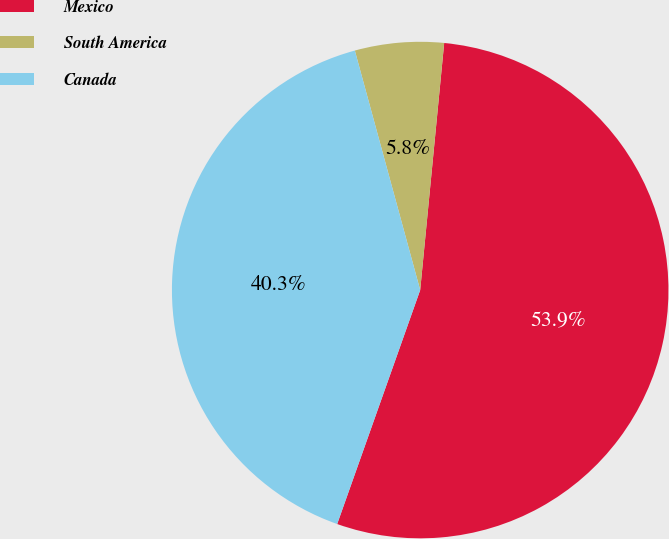Convert chart to OTSL. <chart><loc_0><loc_0><loc_500><loc_500><pie_chart><fcel>Mexico<fcel>South America<fcel>Canada<nl><fcel>53.88%<fcel>5.78%<fcel>40.33%<nl></chart> 